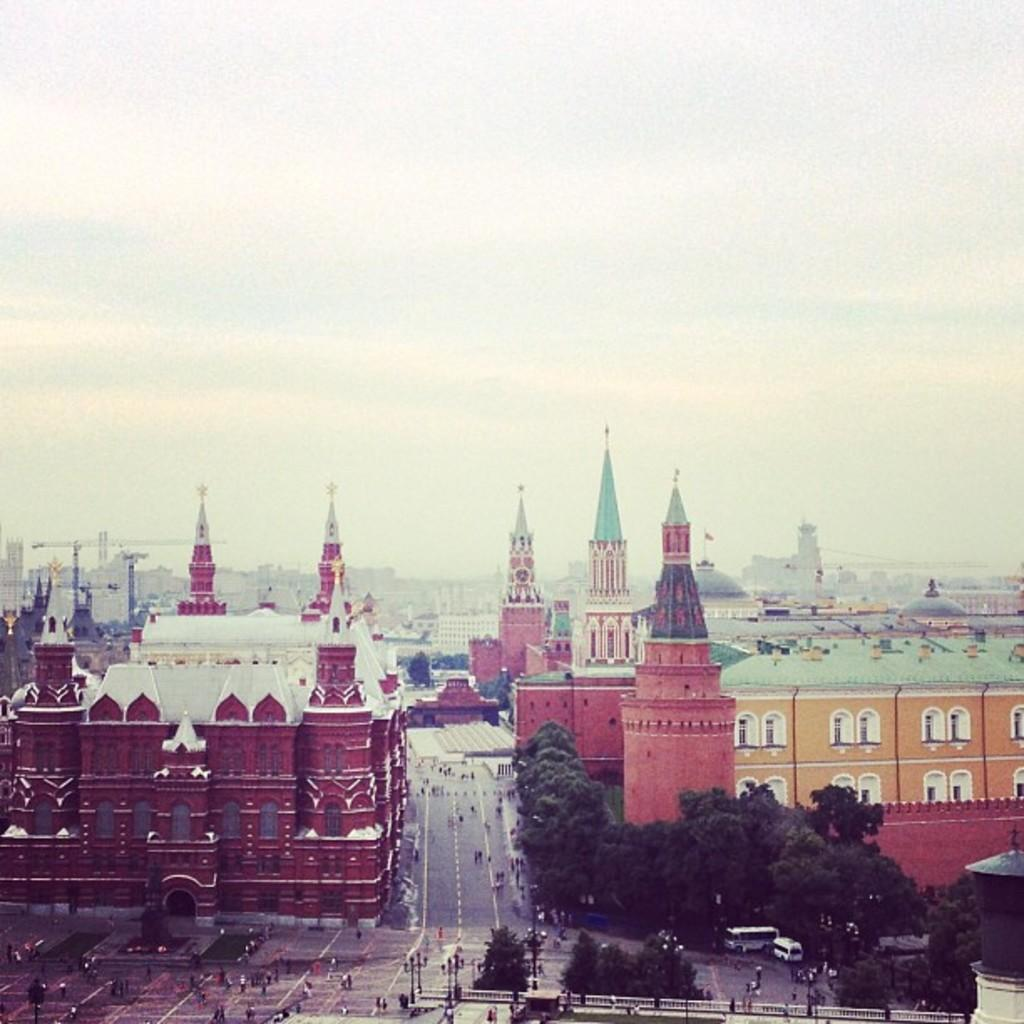What type of structures can be seen in the image? There are buildings with windows in the image. What other elements are present in the image besides buildings? There are trees, vehicles, and people on the roads in the image. What can be seen in the background of the image? The sky is visible in the background of the image. What type of yarn is being used to create the circle in the image? There is no yarn or circle present in the image. How many spoons can be seen in the image? There are no spoons visible in the image. 